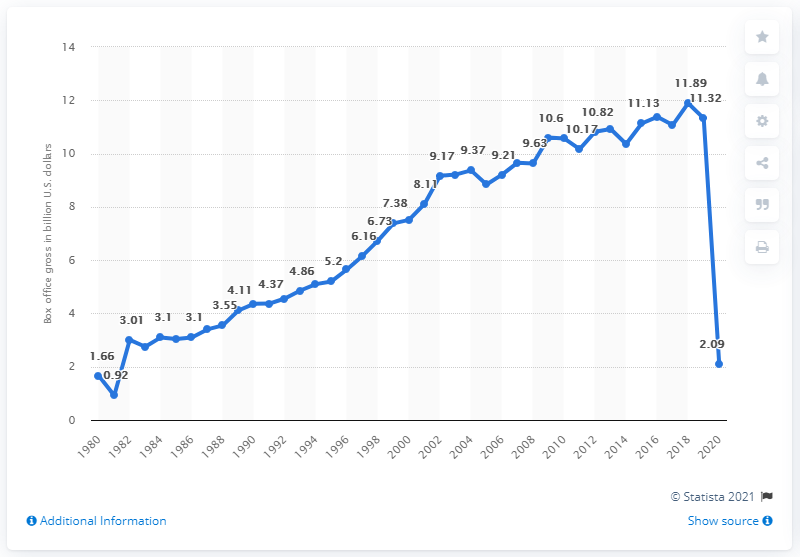Highlight a few significant elements in this photo. The total earnings at the North American box office in 2020 were approximately 2.09 billion dollars. 